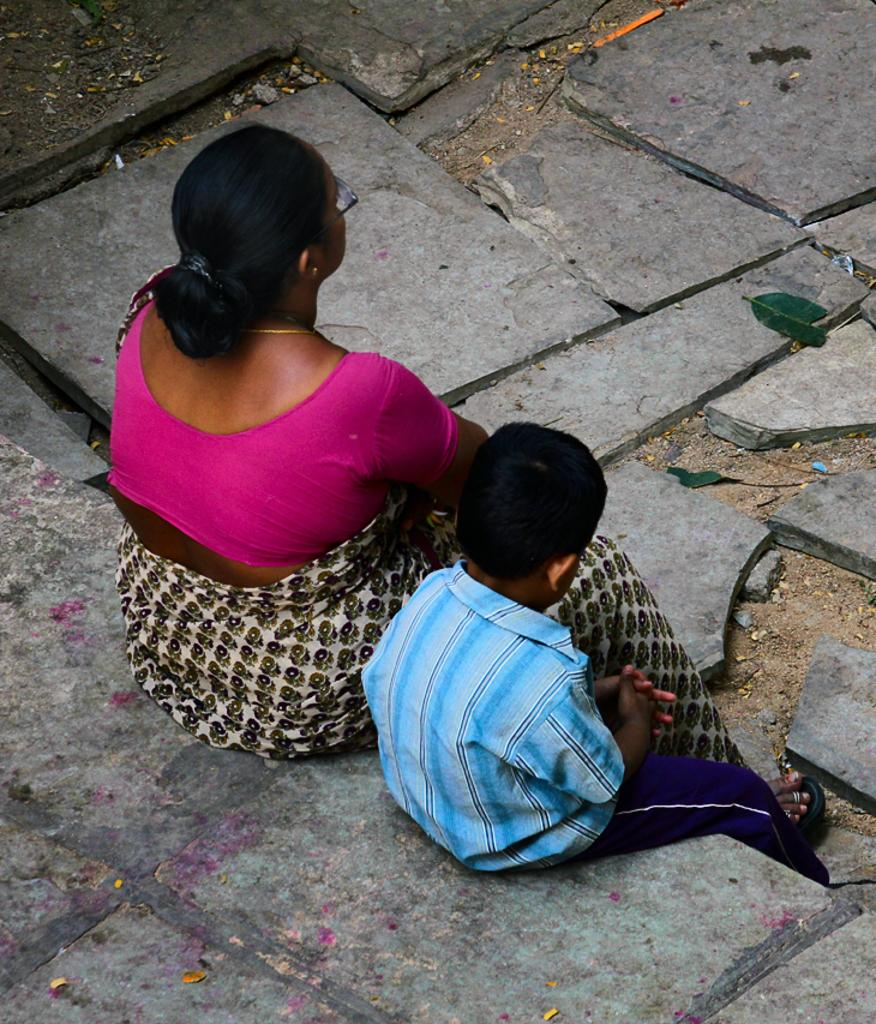How many people are in the image? There are two persons in the image. Can you describe the age of one of the persons? One of the persons is a kid. What are the persons in the image wearing? Both persons are wearing clothes. What type of flooring is visible in the image? There are granite tiles on the ground in the image. What type of copper can be seen in the image? There is no copper present in the image. 